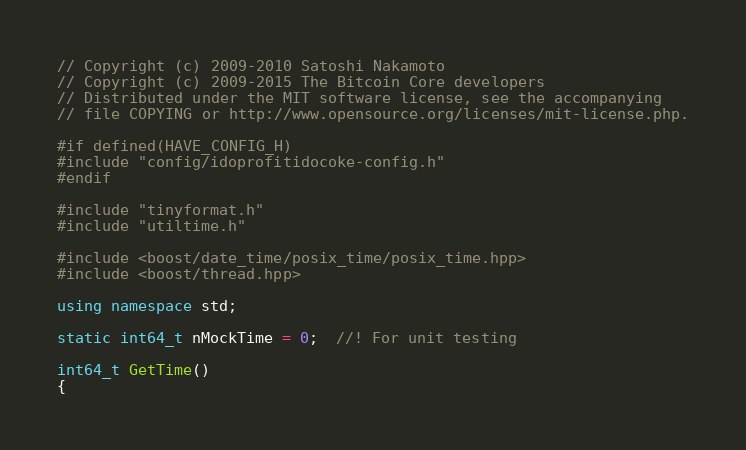<code> <loc_0><loc_0><loc_500><loc_500><_C++_>// Copyright (c) 2009-2010 Satoshi Nakamoto
// Copyright (c) 2009-2015 The Bitcoin Core developers
// Distributed under the MIT software license, see the accompanying
// file COPYING or http://www.opensource.org/licenses/mit-license.php.

#if defined(HAVE_CONFIG_H)
#include "config/idoprofitidocoke-config.h"
#endif

#include "tinyformat.h"
#include "utiltime.h"

#include <boost/date_time/posix_time/posix_time.hpp>
#include <boost/thread.hpp>

using namespace std;

static int64_t nMockTime = 0;  //! For unit testing

int64_t GetTime()
{</code> 